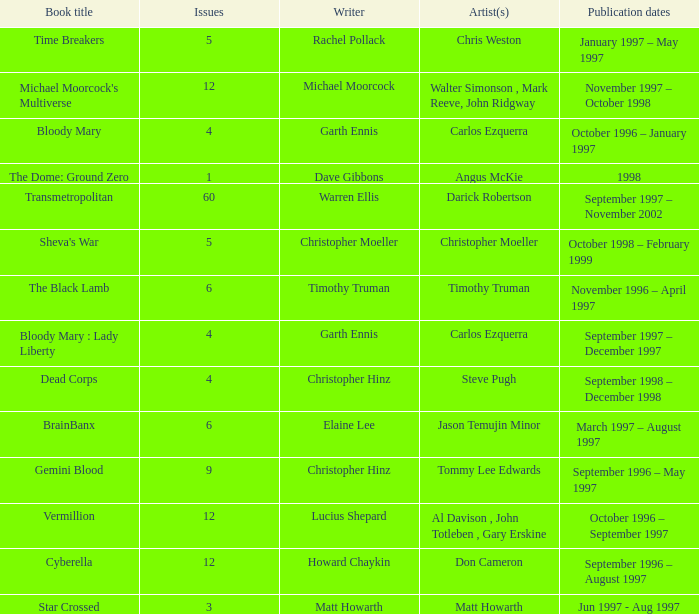Can you parse all the data within this table? {'header': ['Book title', 'Issues', 'Writer', 'Artist(s)', 'Publication dates'], 'rows': [['Time Breakers', '5', 'Rachel Pollack', 'Chris Weston', 'January 1997 – May 1997'], ["Michael Moorcock's Multiverse", '12', 'Michael Moorcock', 'Walter Simonson , Mark Reeve, John Ridgway', 'November 1997 – October 1998'], ['Bloody Mary', '4', 'Garth Ennis', 'Carlos Ezquerra', 'October 1996 – January 1997'], ['The Dome: Ground Zero', '1', 'Dave Gibbons', 'Angus McKie', '1998'], ['Transmetropolitan', '60', 'Warren Ellis', 'Darick Robertson', 'September 1997 – November 2002'], ["Sheva's War", '5', 'Christopher Moeller', 'Christopher Moeller', 'October 1998 – February 1999'], ['The Black Lamb', '6', 'Timothy Truman', 'Timothy Truman', 'November 1996 – April 1997'], ['Bloody Mary : Lady Liberty', '4', 'Garth Ennis', 'Carlos Ezquerra', 'September 1997 – December 1997'], ['Dead Corps', '4', 'Christopher Hinz', 'Steve Pugh', 'September 1998 – December 1998'], ['BrainBanx', '6', 'Elaine Lee', 'Jason Temujin Minor', 'March 1997 – August 1997'], ['Gemini Blood', '9', 'Christopher Hinz', 'Tommy Lee Edwards', 'September 1996 – May 1997'], ['Vermillion', '12', 'Lucius Shepard', 'Al Davison , John Totleben , Gary Erskine', 'October 1996 – September 1997'], ['Cyberella', '12', 'Howard Chaykin', 'Don Cameron', 'September 1996 – August 1997'], ['Star Crossed', '3', 'Matt Howarth', 'Matt Howarth', 'Jun 1997 - Aug 1997']]} What artist has a book called cyberella Don Cameron. 